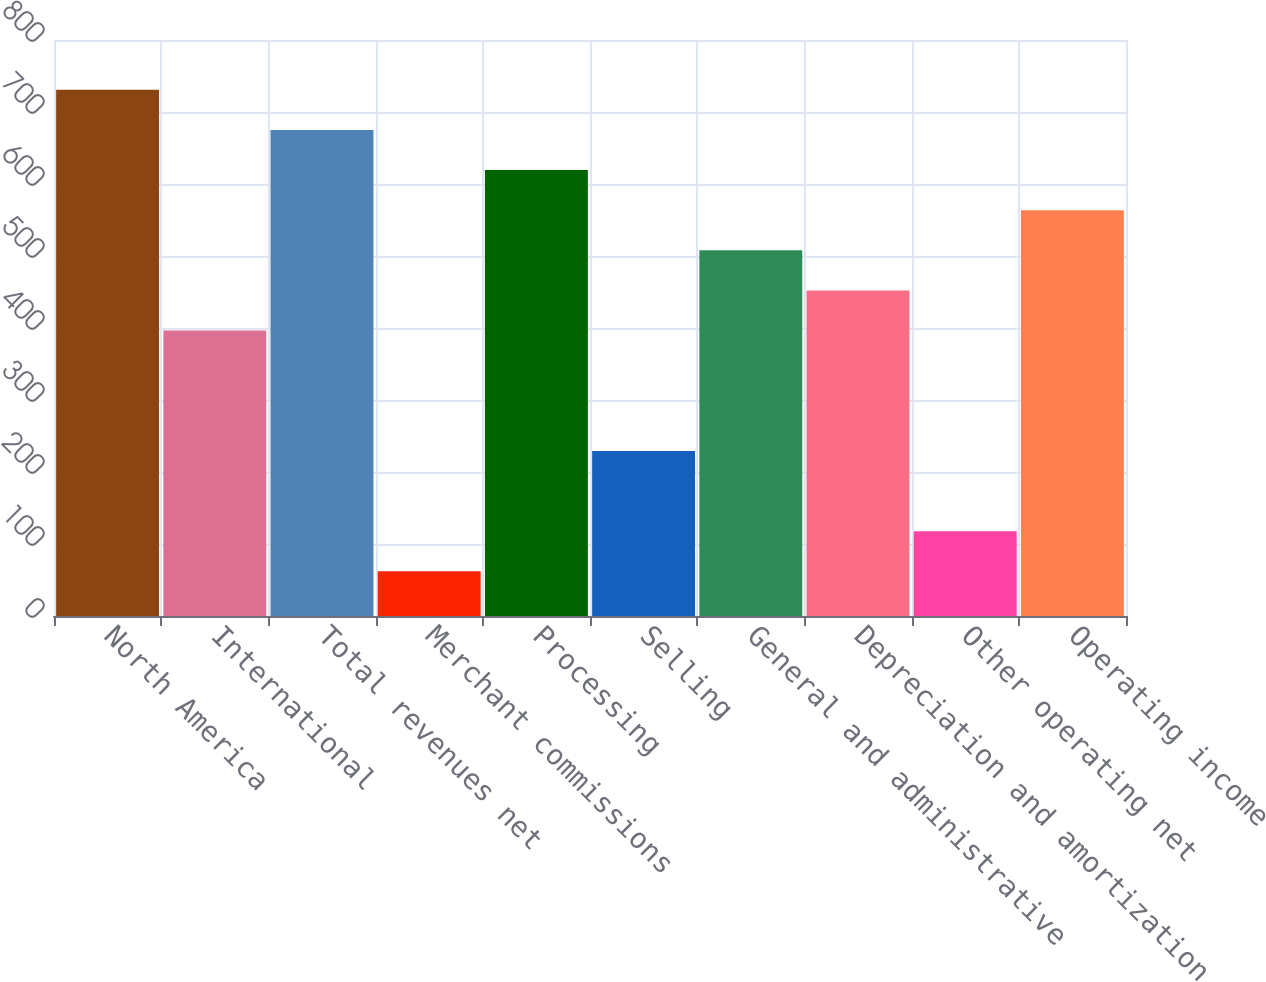Convert chart to OTSL. <chart><loc_0><loc_0><loc_500><loc_500><bar_chart><fcel>North America<fcel>International<fcel>Total revenues net<fcel>Merchant commissions<fcel>Processing<fcel>Selling<fcel>General and administrative<fcel>Depreciation and amortization<fcel>Other operating net<fcel>Operating income<nl><fcel>730.79<fcel>396.41<fcel>675.06<fcel>62.03<fcel>619.33<fcel>229.22<fcel>507.87<fcel>452.14<fcel>117.76<fcel>563.6<nl></chart> 